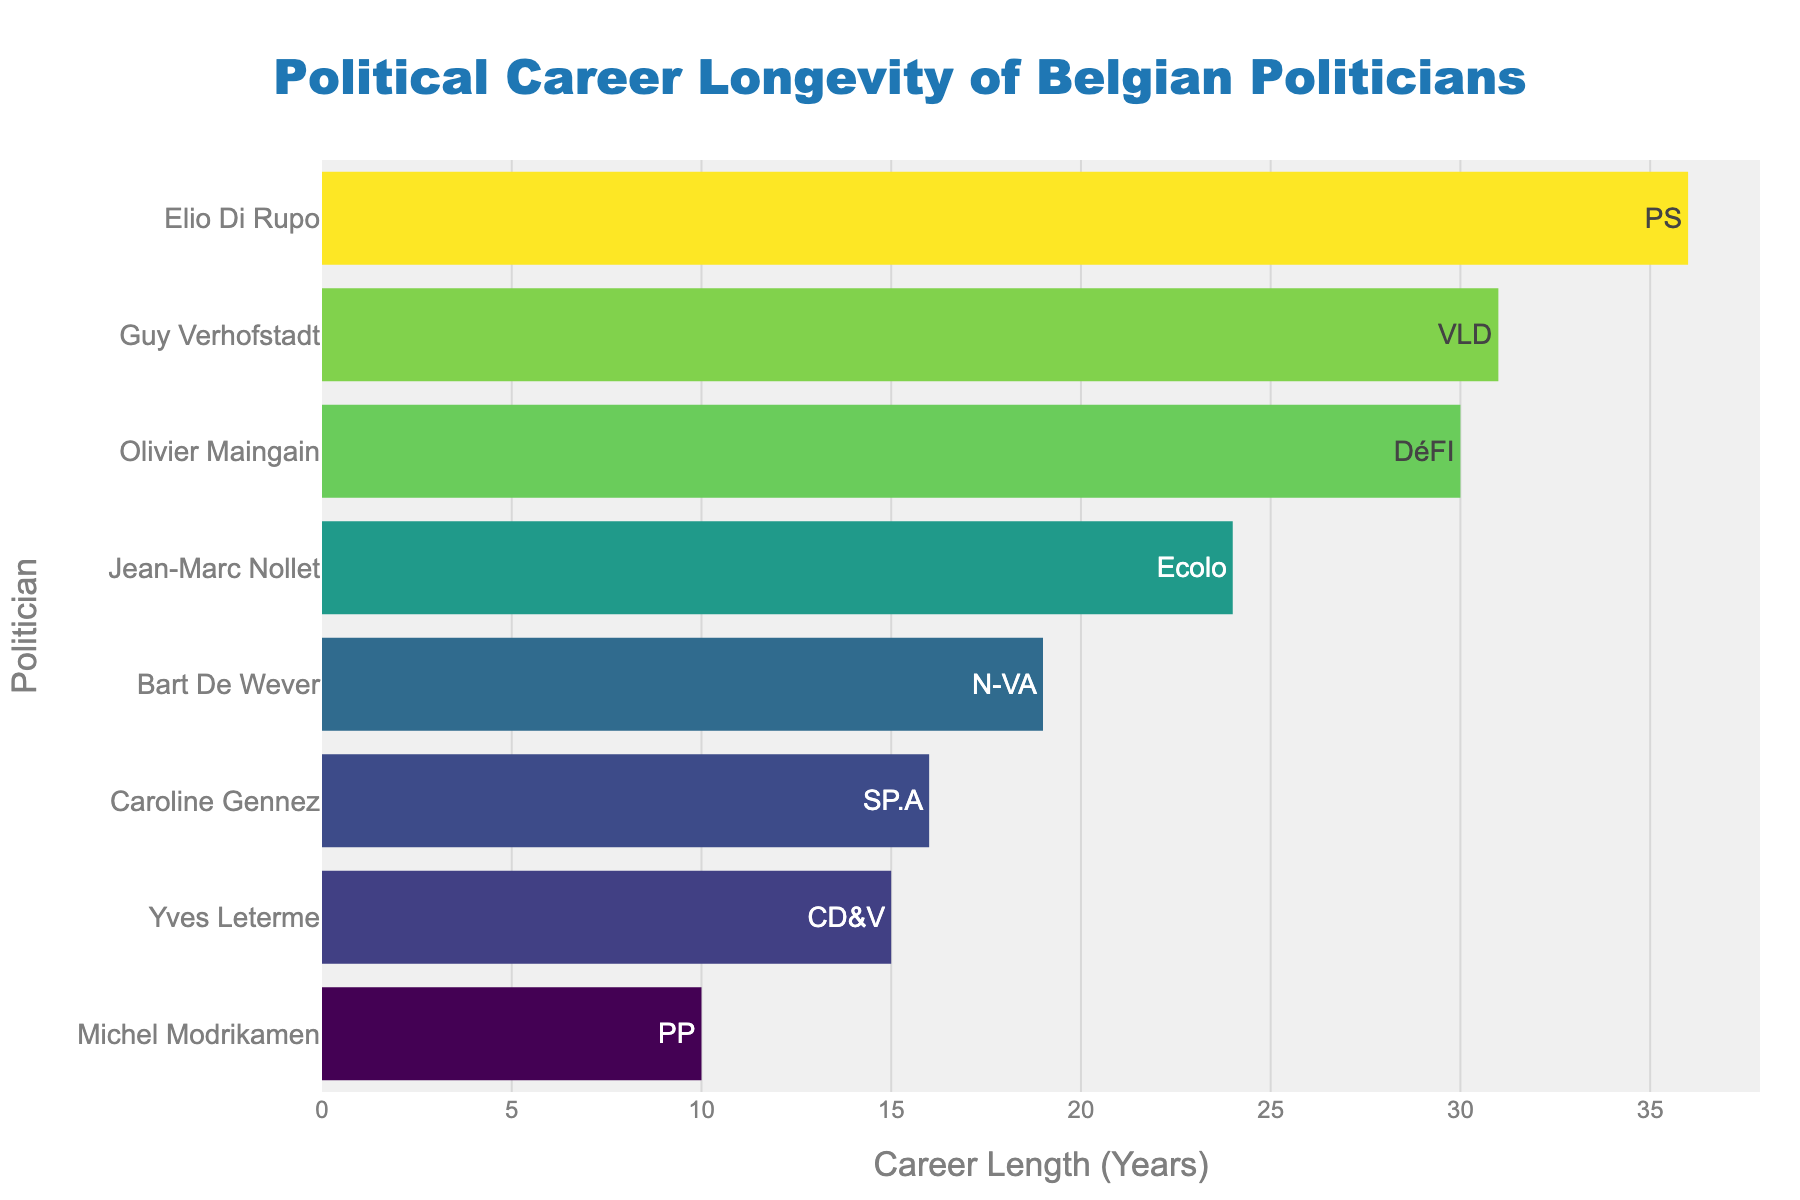Which politician has the longest career according to the figure? Identify the tallest bar in the chart, which represents the longest career length. Hover to reveal the details.
Answer: Elio Di Rupo Which party does the politician with the shortest career belong to? Determine the shortest bar in the chart, hover over it to find the party information in the tooltip.
Answer: PP What's the total career length of all politicians in the N-VA and Ecolo parties combined? Locate bars for N-VA and Ecolo politicians, sum their career lengths. Bart De Wever (N-VA) - 19 years, Jean-Marc Nollet (Ecolo) - 24 years; 19 + 24 = 43
Answer: 43 years Compare the career lengths of Guy Verhofstadt and Yves Leterme. Who served longer and by how many years? Find bars for both politicians. Guy Verhofstadt (1978-2009) - 31 years, Yves Leterme (1999-2014) - 15 years. Difference: 31 - 15 = 16 years
Answer: Guy Verhofstadt by 16 years Which politician's career start year is closest to 2000? Examine hover details for start years near 2000. Caroline Gennez (2007), Bart De Wever (2004), Jean-Marc Nollet (1999). Closest is Bart De Wever (2004).
Answer: Bart De Wever What is the color of the bar representing Olivier Maingain, and what does it indicate? Find Olivier Maingain's bar and note its color. It falls under the "Viridis" scale, indicating a mid-length career.
Answer: Green (indicating a mid-length career) How many politicians had careers spanning more than 20 years? Count bars where career length exceeds 20 years by checking hover details: Elio Di Rupo, Guy Verhofstadt, Jean-Marc Nollet have careers exceeding 20 years.
Answer: 3 politicians What's the average career length of the politicians listed? Sum all career lengths and divide by the number of politicians: (19+36+15+31+24+16+10+30)/8 = 22.625.
Answer: 22.625 years Is there more than one politician from the same party in the chart? Scan the list of parties in hover details, checking for repeated names. No party repeats are present.
Answer: No 